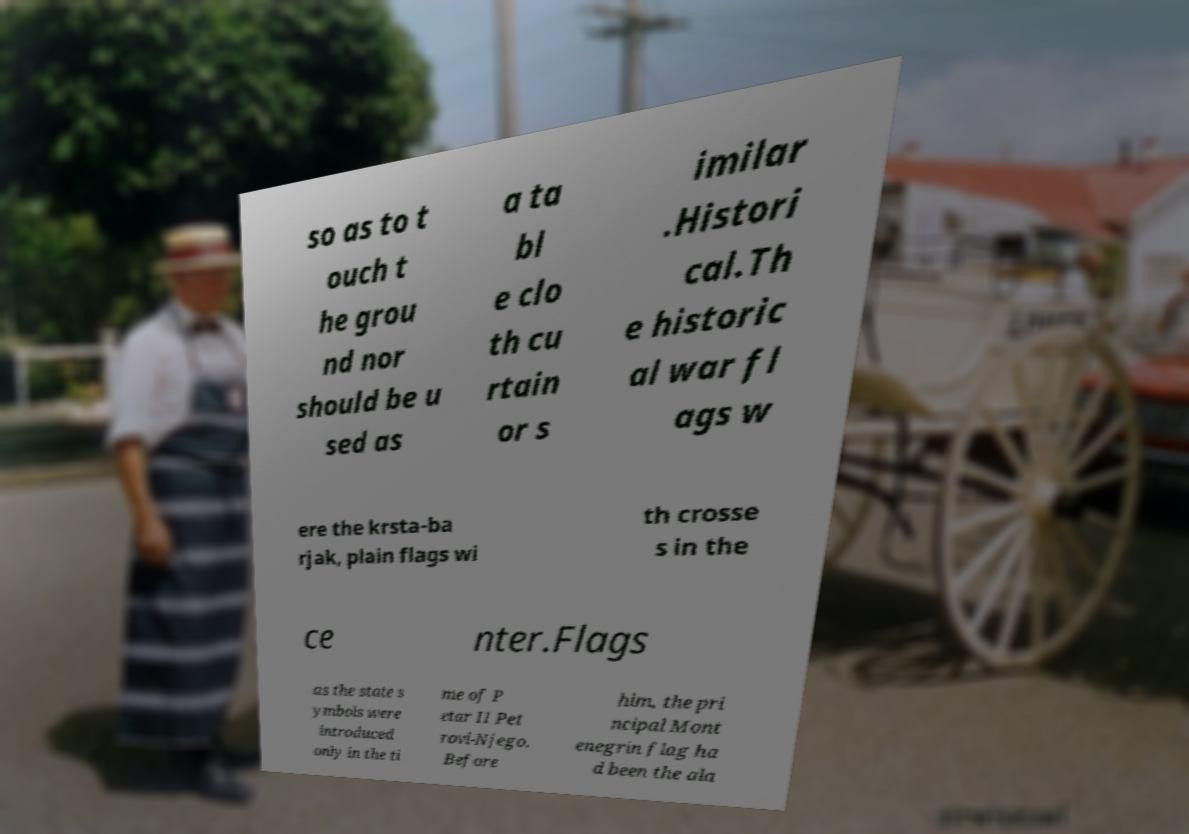Can you accurately transcribe the text from the provided image for me? so as to t ouch t he grou nd nor should be u sed as a ta bl e clo th cu rtain or s imilar .Histori cal.Th e historic al war fl ags w ere the krsta-ba rjak, plain flags wi th crosse s in the ce nter.Flags as the state s ymbols were introduced only in the ti me of P etar II Pet rovi-Njego. Before him, the pri ncipal Mont enegrin flag ha d been the ala 